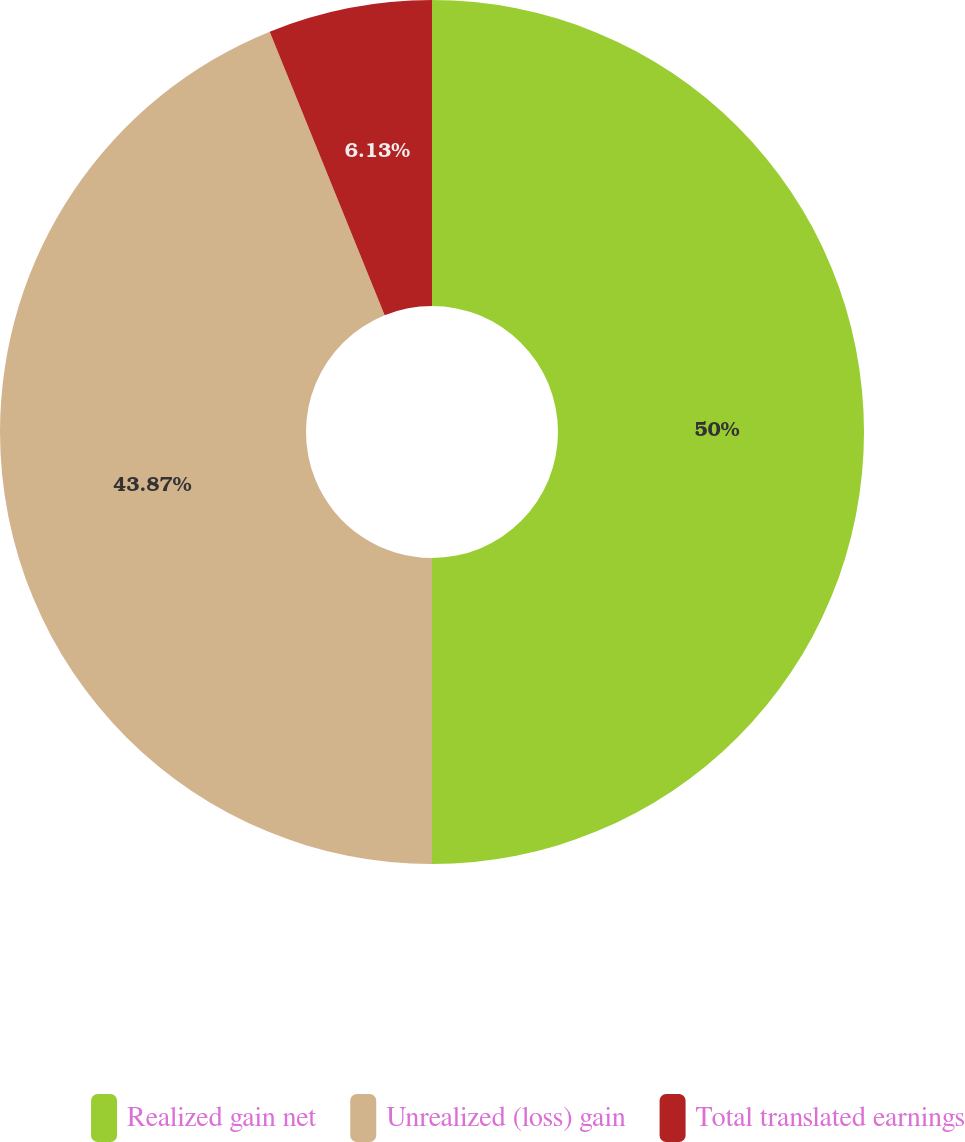Convert chart. <chart><loc_0><loc_0><loc_500><loc_500><pie_chart><fcel>Realized gain net<fcel>Unrealized (loss) gain<fcel>Total translated earnings<nl><fcel>50.0%<fcel>43.87%<fcel>6.13%<nl></chart> 